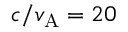Convert formula to latex. <formula><loc_0><loc_0><loc_500><loc_500>c / v _ { A } = 2 0</formula> 